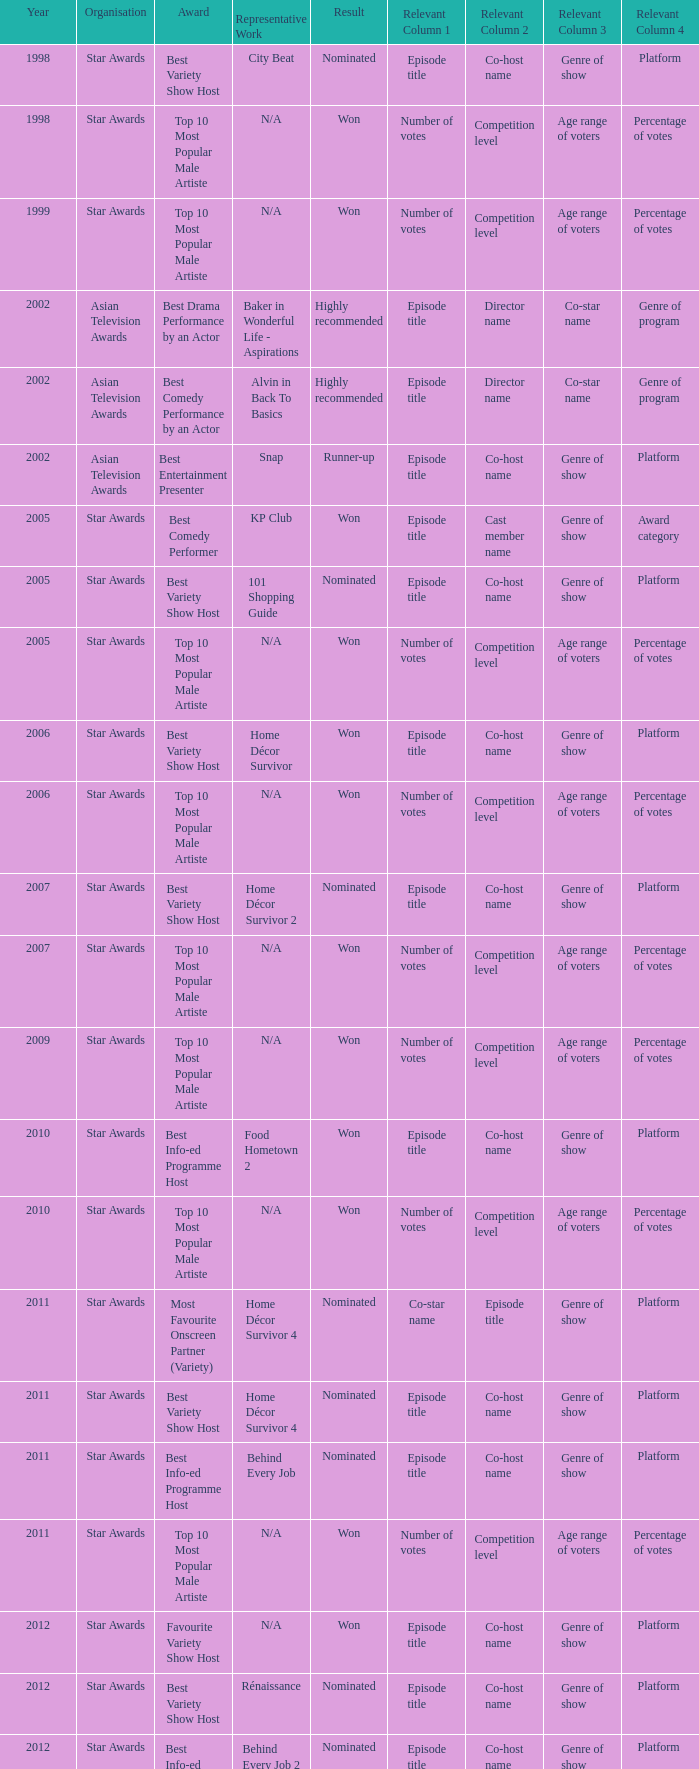What is the award for the Star Awards earlier than 2005 and the result is won? Top 10 Most Popular Male Artiste, Top 10 Most Popular Male Artiste. 